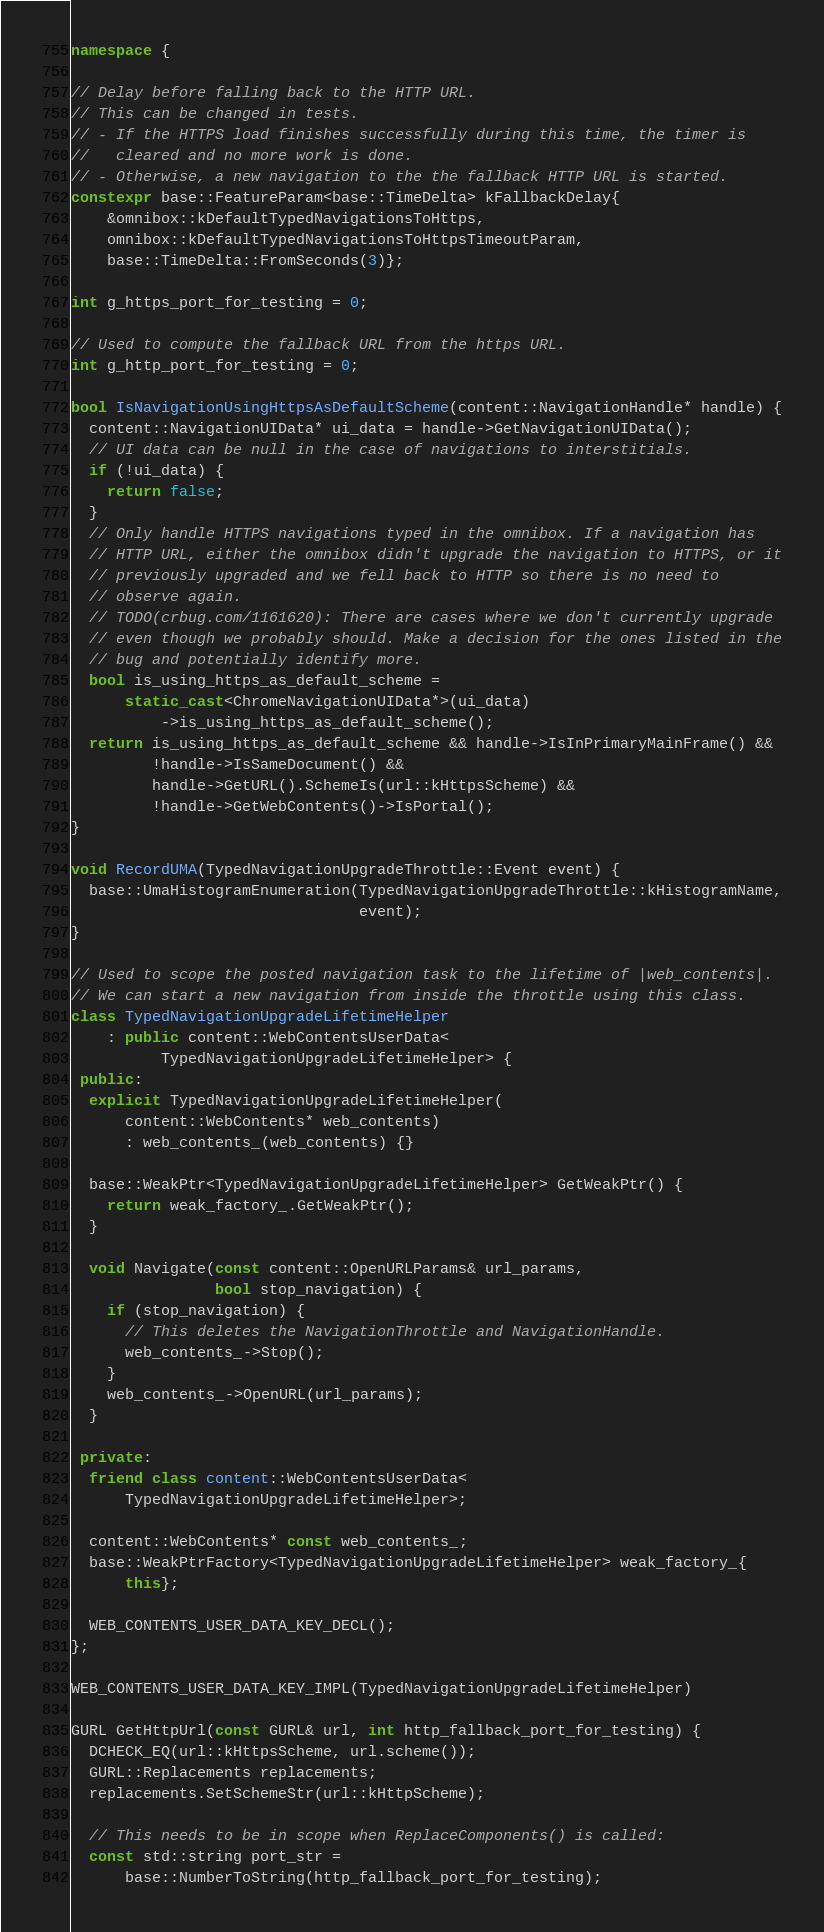Convert code to text. <code><loc_0><loc_0><loc_500><loc_500><_C++_>namespace {

// Delay before falling back to the HTTP URL.
// This can be changed in tests.
// - If the HTTPS load finishes successfully during this time, the timer is
//   cleared and no more work is done.
// - Otherwise, a new navigation to the the fallback HTTP URL is started.
constexpr base::FeatureParam<base::TimeDelta> kFallbackDelay{
    &omnibox::kDefaultTypedNavigationsToHttps,
    omnibox::kDefaultTypedNavigationsToHttpsTimeoutParam,
    base::TimeDelta::FromSeconds(3)};

int g_https_port_for_testing = 0;

// Used to compute the fallback URL from the https URL.
int g_http_port_for_testing = 0;

bool IsNavigationUsingHttpsAsDefaultScheme(content::NavigationHandle* handle) {
  content::NavigationUIData* ui_data = handle->GetNavigationUIData();
  // UI data can be null in the case of navigations to interstitials.
  if (!ui_data) {
    return false;
  }
  // Only handle HTTPS navigations typed in the omnibox. If a navigation has
  // HTTP URL, either the omnibox didn't upgrade the navigation to HTTPS, or it
  // previously upgraded and we fell back to HTTP so there is no need to
  // observe again.
  // TODO(crbug.com/1161620): There are cases where we don't currently upgrade
  // even though we probably should. Make a decision for the ones listed in the
  // bug and potentially identify more.
  bool is_using_https_as_default_scheme =
      static_cast<ChromeNavigationUIData*>(ui_data)
          ->is_using_https_as_default_scheme();
  return is_using_https_as_default_scheme && handle->IsInPrimaryMainFrame() &&
         !handle->IsSameDocument() &&
         handle->GetURL().SchemeIs(url::kHttpsScheme) &&
         !handle->GetWebContents()->IsPortal();
}

void RecordUMA(TypedNavigationUpgradeThrottle::Event event) {
  base::UmaHistogramEnumeration(TypedNavigationUpgradeThrottle::kHistogramName,
                                event);
}

// Used to scope the posted navigation task to the lifetime of |web_contents|.
// We can start a new navigation from inside the throttle using this class.
class TypedNavigationUpgradeLifetimeHelper
    : public content::WebContentsUserData<
          TypedNavigationUpgradeLifetimeHelper> {
 public:
  explicit TypedNavigationUpgradeLifetimeHelper(
      content::WebContents* web_contents)
      : web_contents_(web_contents) {}

  base::WeakPtr<TypedNavigationUpgradeLifetimeHelper> GetWeakPtr() {
    return weak_factory_.GetWeakPtr();
  }

  void Navigate(const content::OpenURLParams& url_params,
                bool stop_navigation) {
    if (stop_navigation) {
      // This deletes the NavigationThrottle and NavigationHandle.
      web_contents_->Stop();
    }
    web_contents_->OpenURL(url_params);
  }

 private:
  friend class content::WebContentsUserData<
      TypedNavigationUpgradeLifetimeHelper>;

  content::WebContents* const web_contents_;
  base::WeakPtrFactory<TypedNavigationUpgradeLifetimeHelper> weak_factory_{
      this};

  WEB_CONTENTS_USER_DATA_KEY_DECL();
};

WEB_CONTENTS_USER_DATA_KEY_IMPL(TypedNavigationUpgradeLifetimeHelper)

GURL GetHttpUrl(const GURL& url, int http_fallback_port_for_testing) {
  DCHECK_EQ(url::kHttpsScheme, url.scheme());
  GURL::Replacements replacements;
  replacements.SetSchemeStr(url::kHttpScheme);

  // This needs to be in scope when ReplaceComponents() is called:
  const std::string port_str =
      base::NumberToString(http_fallback_port_for_testing);</code> 